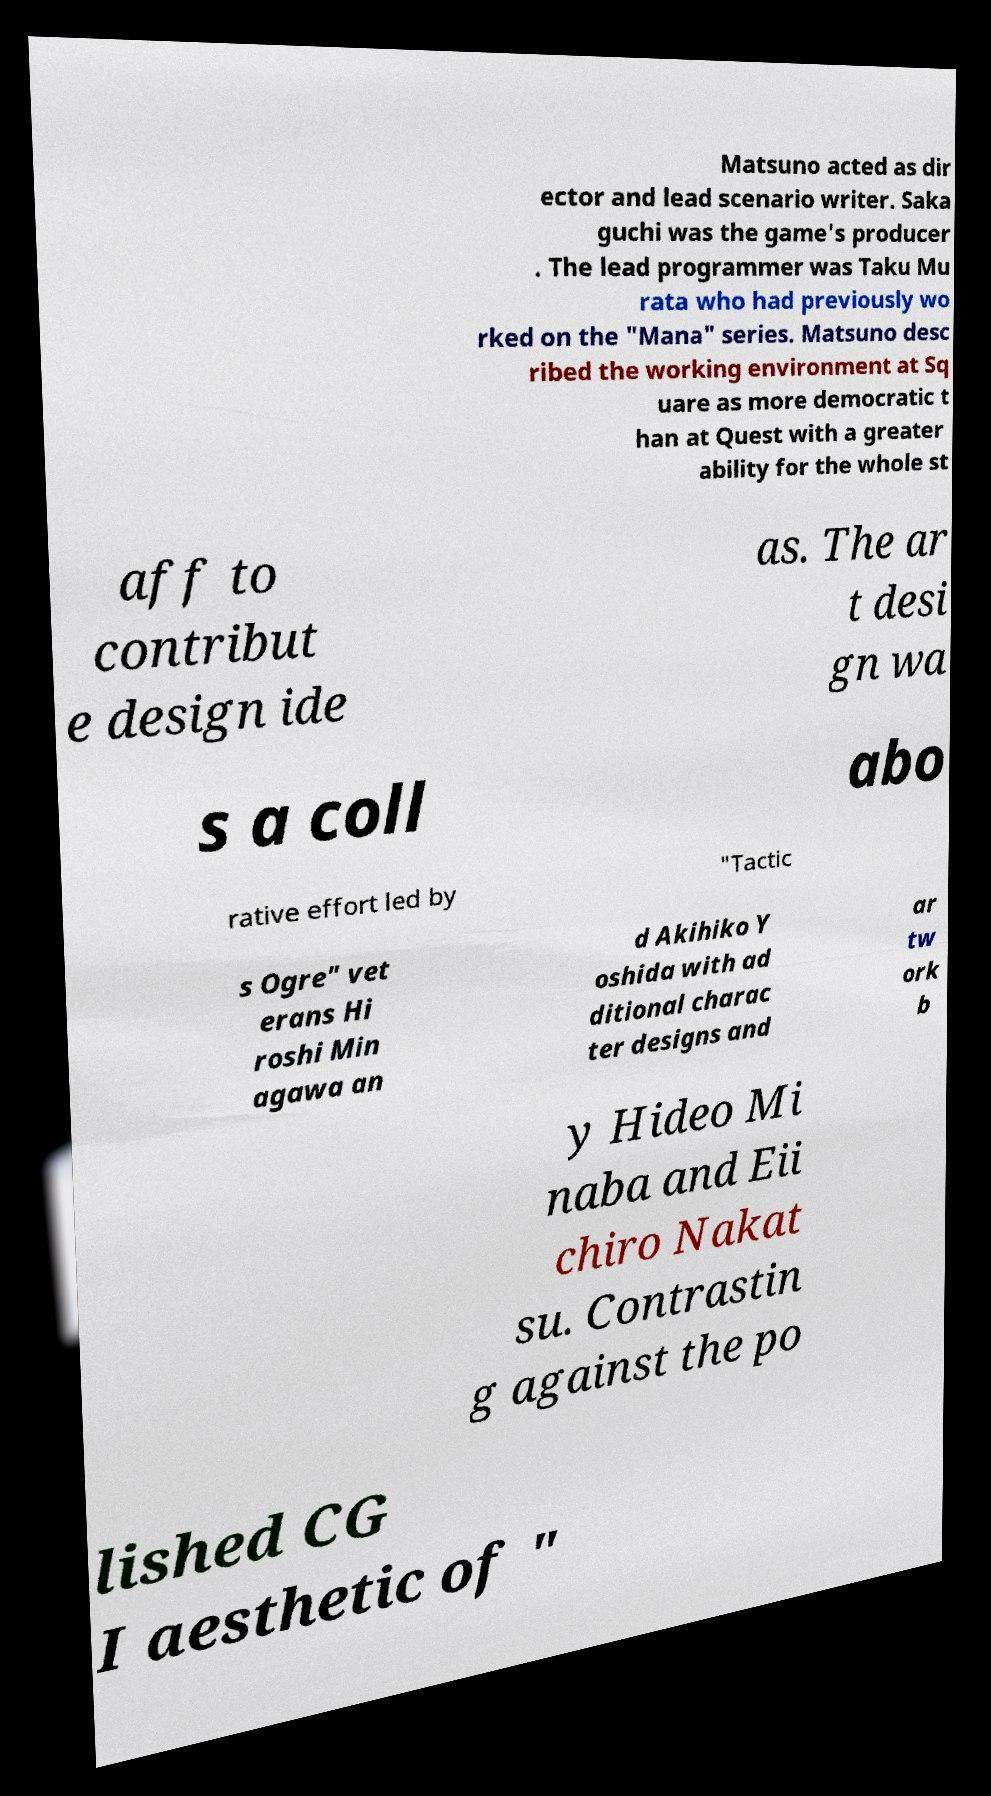What messages or text are displayed in this image? I need them in a readable, typed format. Matsuno acted as dir ector and lead scenario writer. Saka guchi was the game's producer . The lead programmer was Taku Mu rata who had previously wo rked on the "Mana" series. Matsuno desc ribed the working environment at Sq uare as more democratic t han at Quest with a greater ability for the whole st aff to contribut e design ide as. The ar t desi gn wa s a coll abo rative effort led by "Tactic s Ogre" vet erans Hi roshi Min agawa an d Akihiko Y oshida with ad ditional charac ter designs and ar tw ork b y Hideo Mi naba and Eii chiro Nakat su. Contrastin g against the po lished CG I aesthetic of " 